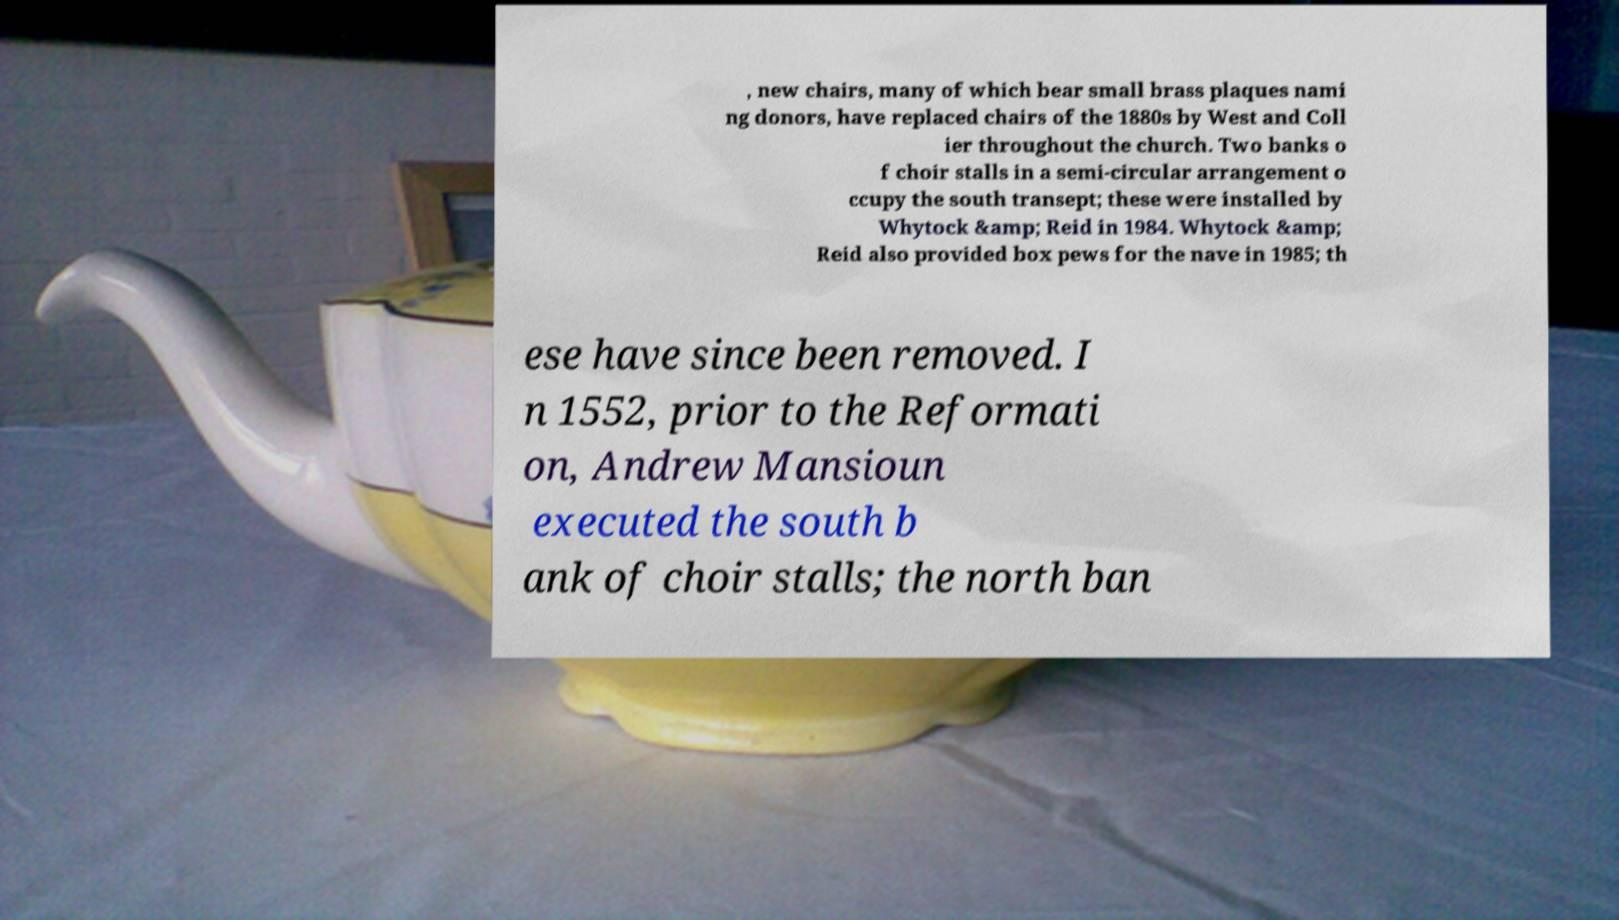Please read and relay the text visible in this image. What does it say? , new chairs, many of which bear small brass plaques nami ng donors, have replaced chairs of the 1880s by West and Coll ier throughout the church. Two banks o f choir stalls in a semi-circular arrangement o ccupy the south transept; these were installed by Whytock &amp; Reid in 1984. Whytock &amp; Reid also provided box pews for the nave in 1985; th ese have since been removed. I n 1552, prior to the Reformati on, Andrew Mansioun executed the south b ank of choir stalls; the north ban 